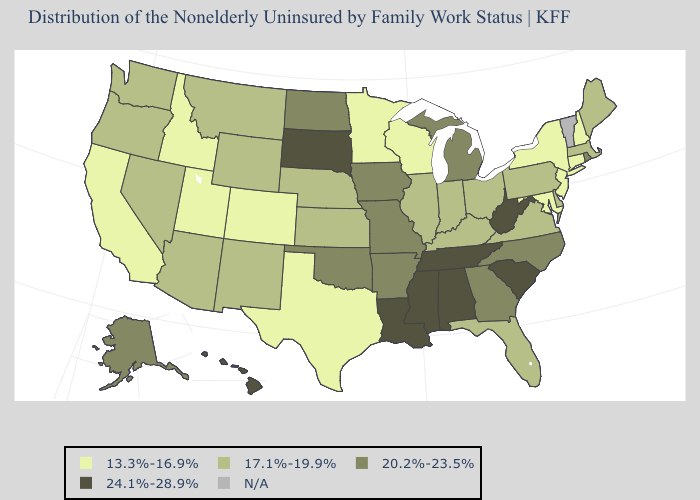Name the states that have a value in the range 13.3%-16.9%?
Answer briefly. California, Colorado, Connecticut, Idaho, Maryland, Minnesota, New Hampshire, New Jersey, New York, Texas, Utah, Wisconsin. Which states have the lowest value in the USA?
Answer briefly. California, Colorado, Connecticut, Idaho, Maryland, Minnesota, New Hampshire, New Jersey, New York, Texas, Utah, Wisconsin. What is the value of Kansas?
Be succinct. 17.1%-19.9%. Among the states that border Arizona , does New Mexico have the lowest value?
Give a very brief answer. No. What is the value of Kansas?
Short answer required. 17.1%-19.9%. Name the states that have a value in the range N/A?
Short answer required. Vermont. Name the states that have a value in the range 13.3%-16.9%?
Quick response, please. California, Colorado, Connecticut, Idaho, Maryland, Minnesota, New Hampshire, New Jersey, New York, Texas, Utah, Wisconsin. What is the lowest value in the South?
Be succinct. 13.3%-16.9%. What is the lowest value in the USA?
Concise answer only. 13.3%-16.9%. What is the highest value in states that border Louisiana?
Write a very short answer. 24.1%-28.9%. Name the states that have a value in the range N/A?
Short answer required. Vermont. What is the value of Mississippi?
Keep it brief. 24.1%-28.9%. Which states hav the highest value in the MidWest?
Answer briefly. South Dakota. 